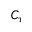Convert formula to latex. <formula><loc_0><loc_0><loc_500><loc_500>C _ { \tau }</formula> 